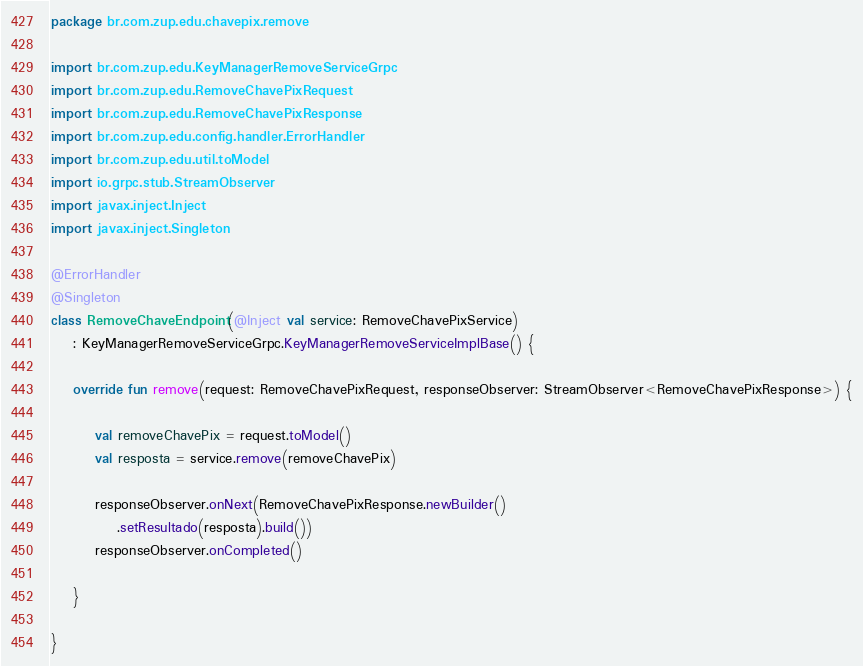<code> <loc_0><loc_0><loc_500><loc_500><_Kotlin_>package br.com.zup.edu.chavepix.remove

import br.com.zup.edu.KeyManagerRemoveServiceGrpc
import br.com.zup.edu.RemoveChavePixRequest
import br.com.zup.edu.RemoveChavePixResponse
import br.com.zup.edu.config.handler.ErrorHandler
import br.com.zup.edu.util.toModel
import io.grpc.stub.StreamObserver
import javax.inject.Inject
import javax.inject.Singleton

@ErrorHandler
@Singleton
class RemoveChaveEndpoint(@Inject val service: RemoveChavePixService)
    : KeyManagerRemoveServiceGrpc.KeyManagerRemoveServiceImplBase() {

    override fun remove(request: RemoveChavePixRequest, responseObserver: StreamObserver<RemoveChavePixResponse>) {

        val removeChavePix = request.toModel()
        val resposta = service.remove(removeChavePix)

        responseObserver.onNext(RemoveChavePixResponse.newBuilder()
            .setResultado(resposta).build())
        responseObserver.onCompleted()

    }

}</code> 